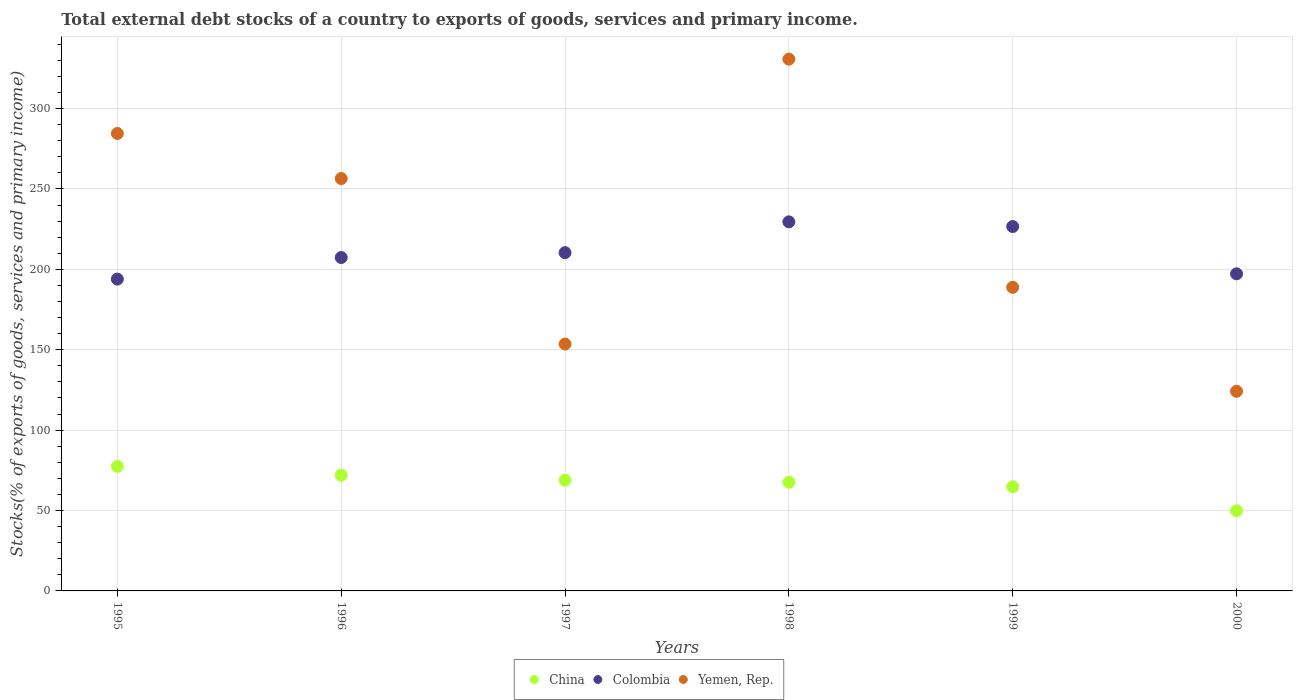How many different coloured dotlines are there?
Give a very brief answer. 3. Is the number of dotlines equal to the number of legend labels?
Your answer should be compact. Yes. What is the total debt stocks in China in 1997?
Offer a terse response. 68.89. Across all years, what is the maximum total debt stocks in Colombia?
Your response must be concise. 229.54. Across all years, what is the minimum total debt stocks in Yemen, Rep.?
Your answer should be very brief. 124.16. In which year was the total debt stocks in Yemen, Rep. maximum?
Provide a short and direct response. 1998. What is the total total debt stocks in China in the graph?
Your response must be concise. 400.57. What is the difference between the total debt stocks in China in 1996 and that in 2000?
Ensure brevity in your answer.  22.11. What is the difference between the total debt stocks in China in 1999 and the total debt stocks in Colombia in 1996?
Your answer should be very brief. -142.57. What is the average total debt stocks in Yemen, Rep. per year?
Offer a very short reply. 223.04. In the year 1998, what is the difference between the total debt stocks in China and total debt stocks in Yemen, Rep.?
Your answer should be compact. -263.14. In how many years, is the total debt stocks in Colombia greater than 200 %?
Ensure brevity in your answer.  4. What is the ratio of the total debt stocks in Colombia in 1995 to that in 1996?
Offer a very short reply. 0.94. What is the difference between the highest and the second highest total debt stocks in Colombia?
Provide a succinct answer. 2.91. What is the difference between the highest and the lowest total debt stocks in Colombia?
Your answer should be very brief. 35.61. Does the total debt stocks in Yemen, Rep. monotonically increase over the years?
Offer a terse response. No. How many dotlines are there?
Give a very brief answer. 3. How many years are there in the graph?
Provide a succinct answer. 6. What is the difference between two consecutive major ticks on the Y-axis?
Your answer should be compact. 50. Does the graph contain any zero values?
Make the answer very short. No. Where does the legend appear in the graph?
Make the answer very short. Bottom center. How many legend labels are there?
Make the answer very short. 3. How are the legend labels stacked?
Offer a very short reply. Horizontal. What is the title of the graph?
Your answer should be very brief. Total external debt stocks of a country to exports of goods, services and primary income. Does "Low income" appear as one of the legend labels in the graph?
Your answer should be very brief. No. What is the label or title of the Y-axis?
Your response must be concise. Stocks(% of exports of goods, services and primary income). What is the Stocks(% of exports of goods, services and primary income) of China in 1995?
Provide a succinct answer. 77.47. What is the Stocks(% of exports of goods, services and primary income) of Colombia in 1995?
Provide a succinct answer. 193.93. What is the Stocks(% of exports of goods, services and primary income) of Yemen, Rep. in 1995?
Your answer should be very brief. 284.52. What is the Stocks(% of exports of goods, services and primary income) of China in 1996?
Ensure brevity in your answer.  71.97. What is the Stocks(% of exports of goods, services and primary income) of Colombia in 1996?
Your response must be concise. 207.36. What is the Stocks(% of exports of goods, services and primary income) in Yemen, Rep. in 1996?
Offer a terse response. 256.49. What is the Stocks(% of exports of goods, services and primary income) in China in 1997?
Ensure brevity in your answer.  68.89. What is the Stocks(% of exports of goods, services and primary income) of Colombia in 1997?
Provide a short and direct response. 210.38. What is the Stocks(% of exports of goods, services and primary income) in Yemen, Rep. in 1997?
Offer a very short reply. 153.54. What is the Stocks(% of exports of goods, services and primary income) in China in 1998?
Offer a very short reply. 67.59. What is the Stocks(% of exports of goods, services and primary income) in Colombia in 1998?
Provide a short and direct response. 229.54. What is the Stocks(% of exports of goods, services and primary income) in Yemen, Rep. in 1998?
Offer a very short reply. 330.74. What is the Stocks(% of exports of goods, services and primary income) of China in 1999?
Provide a succinct answer. 64.79. What is the Stocks(% of exports of goods, services and primary income) of Colombia in 1999?
Provide a short and direct response. 226.63. What is the Stocks(% of exports of goods, services and primary income) in Yemen, Rep. in 1999?
Your answer should be compact. 188.81. What is the Stocks(% of exports of goods, services and primary income) of China in 2000?
Provide a short and direct response. 49.86. What is the Stocks(% of exports of goods, services and primary income) of Colombia in 2000?
Provide a succinct answer. 197.22. What is the Stocks(% of exports of goods, services and primary income) in Yemen, Rep. in 2000?
Offer a very short reply. 124.16. Across all years, what is the maximum Stocks(% of exports of goods, services and primary income) in China?
Give a very brief answer. 77.47. Across all years, what is the maximum Stocks(% of exports of goods, services and primary income) of Colombia?
Keep it short and to the point. 229.54. Across all years, what is the maximum Stocks(% of exports of goods, services and primary income) in Yemen, Rep.?
Provide a succinct answer. 330.74. Across all years, what is the minimum Stocks(% of exports of goods, services and primary income) of China?
Provide a short and direct response. 49.86. Across all years, what is the minimum Stocks(% of exports of goods, services and primary income) in Colombia?
Offer a very short reply. 193.93. Across all years, what is the minimum Stocks(% of exports of goods, services and primary income) of Yemen, Rep.?
Your answer should be very brief. 124.16. What is the total Stocks(% of exports of goods, services and primary income) in China in the graph?
Ensure brevity in your answer.  400.57. What is the total Stocks(% of exports of goods, services and primary income) of Colombia in the graph?
Provide a short and direct response. 1265.05. What is the total Stocks(% of exports of goods, services and primary income) in Yemen, Rep. in the graph?
Offer a very short reply. 1338.26. What is the difference between the Stocks(% of exports of goods, services and primary income) of China in 1995 and that in 1996?
Keep it short and to the point. 5.5. What is the difference between the Stocks(% of exports of goods, services and primary income) in Colombia in 1995 and that in 1996?
Provide a short and direct response. -13.44. What is the difference between the Stocks(% of exports of goods, services and primary income) in Yemen, Rep. in 1995 and that in 1996?
Your response must be concise. 28.03. What is the difference between the Stocks(% of exports of goods, services and primary income) in China in 1995 and that in 1997?
Give a very brief answer. 8.58. What is the difference between the Stocks(% of exports of goods, services and primary income) in Colombia in 1995 and that in 1997?
Give a very brief answer. -16.46. What is the difference between the Stocks(% of exports of goods, services and primary income) of Yemen, Rep. in 1995 and that in 1997?
Your answer should be very brief. 130.98. What is the difference between the Stocks(% of exports of goods, services and primary income) of China in 1995 and that in 1998?
Your answer should be very brief. 9.88. What is the difference between the Stocks(% of exports of goods, services and primary income) in Colombia in 1995 and that in 1998?
Provide a short and direct response. -35.61. What is the difference between the Stocks(% of exports of goods, services and primary income) in Yemen, Rep. in 1995 and that in 1998?
Your response must be concise. -46.21. What is the difference between the Stocks(% of exports of goods, services and primary income) of China in 1995 and that in 1999?
Provide a succinct answer. 12.68. What is the difference between the Stocks(% of exports of goods, services and primary income) in Colombia in 1995 and that in 1999?
Provide a short and direct response. -32.7. What is the difference between the Stocks(% of exports of goods, services and primary income) in Yemen, Rep. in 1995 and that in 1999?
Your answer should be compact. 95.71. What is the difference between the Stocks(% of exports of goods, services and primary income) of China in 1995 and that in 2000?
Give a very brief answer. 27.61. What is the difference between the Stocks(% of exports of goods, services and primary income) of Colombia in 1995 and that in 2000?
Provide a succinct answer. -3.29. What is the difference between the Stocks(% of exports of goods, services and primary income) of Yemen, Rep. in 1995 and that in 2000?
Keep it short and to the point. 160.36. What is the difference between the Stocks(% of exports of goods, services and primary income) of China in 1996 and that in 1997?
Offer a terse response. 3.08. What is the difference between the Stocks(% of exports of goods, services and primary income) of Colombia in 1996 and that in 1997?
Your response must be concise. -3.02. What is the difference between the Stocks(% of exports of goods, services and primary income) of Yemen, Rep. in 1996 and that in 1997?
Your answer should be compact. 102.95. What is the difference between the Stocks(% of exports of goods, services and primary income) of China in 1996 and that in 1998?
Your response must be concise. 4.37. What is the difference between the Stocks(% of exports of goods, services and primary income) in Colombia in 1996 and that in 1998?
Offer a terse response. -22.17. What is the difference between the Stocks(% of exports of goods, services and primary income) in Yemen, Rep. in 1996 and that in 1998?
Your answer should be compact. -74.24. What is the difference between the Stocks(% of exports of goods, services and primary income) of China in 1996 and that in 1999?
Give a very brief answer. 7.17. What is the difference between the Stocks(% of exports of goods, services and primary income) in Colombia in 1996 and that in 1999?
Your response must be concise. -19.26. What is the difference between the Stocks(% of exports of goods, services and primary income) in Yemen, Rep. in 1996 and that in 1999?
Give a very brief answer. 67.68. What is the difference between the Stocks(% of exports of goods, services and primary income) of China in 1996 and that in 2000?
Keep it short and to the point. 22.11. What is the difference between the Stocks(% of exports of goods, services and primary income) in Colombia in 1996 and that in 2000?
Give a very brief answer. 10.14. What is the difference between the Stocks(% of exports of goods, services and primary income) of Yemen, Rep. in 1996 and that in 2000?
Offer a terse response. 132.33. What is the difference between the Stocks(% of exports of goods, services and primary income) in China in 1997 and that in 1998?
Offer a very short reply. 1.29. What is the difference between the Stocks(% of exports of goods, services and primary income) of Colombia in 1997 and that in 1998?
Your answer should be very brief. -19.15. What is the difference between the Stocks(% of exports of goods, services and primary income) of Yemen, Rep. in 1997 and that in 1998?
Your answer should be compact. -177.2. What is the difference between the Stocks(% of exports of goods, services and primary income) of China in 1997 and that in 1999?
Provide a succinct answer. 4.1. What is the difference between the Stocks(% of exports of goods, services and primary income) in Colombia in 1997 and that in 1999?
Provide a succinct answer. -16.24. What is the difference between the Stocks(% of exports of goods, services and primary income) of Yemen, Rep. in 1997 and that in 1999?
Keep it short and to the point. -35.27. What is the difference between the Stocks(% of exports of goods, services and primary income) of China in 1997 and that in 2000?
Give a very brief answer. 19.03. What is the difference between the Stocks(% of exports of goods, services and primary income) of Colombia in 1997 and that in 2000?
Your answer should be very brief. 13.16. What is the difference between the Stocks(% of exports of goods, services and primary income) of Yemen, Rep. in 1997 and that in 2000?
Ensure brevity in your answer.  29.37. What is the difference between the Stocks(% of exports of goods, services and primary income) of China in 1998 and that in 1999?
Offer a terse response. 2.8. What is the difference between the Stocks(% of exports of goods, services and primary income) in Colombia in 1998 and that in 1999?
Provide a short and direct response. 2.91. What is the difference between the Stocks(% of exports of goods, services and primary income) in Yemen, Rep. in 1998 and that in 1999?
Your answer should be very brief. 141.92. What is the difference between the Stocks(% of exports of goods, services and primary income) of China in 1998 and that in 2000?
Give a very brief answer. 17.73. What is the difference between the Stocks(% of exports of goods, services and primary income) of Colombia in 1998 and that in 2000?
Make the answer very short. 32.31. What is the difference between the Stocks(% of exports of goods, services and primary income) in Yemen, Rep. in 1998 and that in 2000?
Keep it short and to the point. 206.57. What is the difference between the Stocks(% of exports of goods, services and primary income) in China in 1999 and that in 2000?
Provide a short and direct response. 14.93. What is the difference between the Stocks(% of exports of goods, services and primary income) of Colombia in 1999 and that in 2000?
Your answer should be very brief. 29.41. What is the difference between the Stocks(% of exports of goods, services and primary income) of Yemen, Rep. in 1999 and that in 2000?
Your response must be concise. 64.65. What is the difference between the Stocks(% of exports of goods, services and primary income) of China in 1995 and the Stocks(% of exports of goods, services and primary income) of Colombia in 1996?
Your answer should be compact. -129.89. What is the difference between the Stocks(% of exports of goods, services and primary income) in China in 1995 and the Stocks(% of exports of goods, services and primary income) in Yemen, Rep. in 1996?
Your answer should be very brief. -179.02. What is the difference between the Stocks(% of exports of goods, services and primary income) in Colombia in 1995 and the Stocks(% of exports of goods, services and primary income) in Yemen, Rep. in 1996?
Keep it short and to the point. -62.57. What is the difference between the Stocks(% of exports of goods, services and primary income) of China in 1995 and the Stocks(% of exports of goods, services and primary income) of Colombia in 1997?
Offer a terse response. -132.91. What is the difference between the Stocks(% of exports of goods, services and primary income) of China in 1995 and the Stocks(% of exports of goods, services and primary income) of Yemen, Rep. in 1997?
Your answer should be very brief. -76.07. What is the difference between the Stocks(% of exports of goods, services and primary income) of Colombia in 1995 and the Stocks(% of exports of goods, services and primary income) of Yemen, Rep. in 1997?
Provide a succinct answer. 40.39. What is the difference between the Stocks(% of exports of goods, services and primary income) in China in 1995 and the Stocks(% of exports of goods, services and primary income) in Colombia in 1998?
Provide a succinct answer. -152.06. What is the difference between the Stocks(% of exports of goods, services and primary income) of China in 1995 and the Stocks(% of exports of goods, services and primary income) of Yemen, Rep. in 1998?
Keep it short and to the point. -253.26. What is the difference between the Stocks(% of exports of goods, services and primary income) of Colombia in 1995 and the Stocks(% of exports of goods, services and primary income) of Yemen, Rep. in 1998?
Keep it short and to the point. -136.81. What is the difference between the Stocks(% of exports of goods, services and primary income) of China in 1995 and the Stocks(% of exports of goods, services and primary income) of Colombia in 1999?
Provide a succinct answer. -149.16. What is the difference between the Stocks(% of exports of goods, services and primary income) of China in 1995 and the Stocks(% of exports of goods, services and primary income) of Yemen, Rep. in 1999?
Offer a very short reply. -111.34. What is the difference between the Stocks(% of exports of goods, services and primary income) in Colombia in 1995 and the Stocks(% of exports of goods, services and primary income) in Yemen, Rep. in 1999?
Your response must be concise. 5.11. What is the difference between the Stocks(% of exports of goods, services and primary income) of China in 1995 and the Stocks(% of exports of goods, services and primary income) of Colombia in 2000?
Offer a very short reply. -119.75. What is the difference between the Stocks(% of exports of goods, services and primary income) in China in 1995 and the Stocks(% of exports of goods, services and primary income) in Yemen, Rep. in 2000?
Ensure brevity in your answer.  -46.69. What is the difference between the Stocks(% of exports of goods, services and primary income) in Colombia in 1995 and the Stocks(% of exports of goods, services and primary income) in Yemen, Rep. in 2000?
Provide a succinct answer. 69.76. What is the difference between the Stocks(% of exports of goods, services and primary income) in China in 1996 and the Stocks(% of exports of goods, services and primary income) in Colombia in 1997?
Ensure brevity in your answer.  -138.42. What is the difference between the Stocks(% of exports of goods, services and primary income) of China in 1996 and the Stocks(% of exports of goods, services and primary income) of Yemen, Rep. in 1997?
Your response must be concise. -81.57. What is the difference between the Stocks(% of exports of goods, services and primary income) of Colombia in 1996 and the Stocks(% of exports of goods, services and primary income) of Yemen, Rep. in 1997?
Offer a terse response. 53.82. What is the difference between the Stocks(% of exports of goods, services and primary income) of China in 1996 and the Stocks(% of exports of goods, services and primary income) of Colombia in 1998?
Offer a terse response. -157.57. What is the difference between the Stocks(% of exports of goods, services and primary income) of China in 1996 and the Stocks(% of exports of goods, services and primary income) of Yemen, Rep. in 1998?
Your answer should be compact. -258.77. What is the difference between the Stocks(% of exports of goods, services and primary income) of Colombia in 1996 and the Stocks(% of exports of goods, services and primary income) of Yemen, Rep. in 1998?
Make the answer very short. -123.37. What is the difference between the Stocks(% of exports of goods, services and primary income) in China in 1996 and the Stocks(% of exports of goods, services and primary income) in Colombia in 1999?
Offer a terse response. -154.66. What is the difference between the Stocks(% of exports of goods, services and primary income) in China in 1996 and the Stocks(% of exports of goods, services and primary income) in Yemen, Rep. in 1999?
Your response must be concise. -116.85. What is the difference between the Stocks(% of exports of goods, services and primary income) in Colombia in 1996 and the Stocks(% of exports of goods, services and primary income) in Yemen, Rep. in 1999?
Provide a succinct answer. 18.55. What is the difference between the Stocks(% of exports of goods, services and primary income) in China in 1996 and the Stocks(% of exports of goods, services and primary income) in Colombia in 2000?
Offer a terse response. -125.25. What is the difference between the Stocks(% of exports of goods, services and primary income) in China in 1996 and the Stocks(% of exports of goods, services and primary income) in Yemen, Rep. in 2000?
Your answer should be compact. -52.2. What is the difference between the Stocks(% of exports of goods, services and primary income) of Colombia in 1996 and the Stocks(% of exports of goods, services and primary income) of Yemen, Rep. in 2000?
Provide a succinct answer. 83.2. What is the difference between the Stocks(% of exports of goods, services and primary income) of China in 1997 and the Stocks(% of exports of goods, services and primary income) of Colombia in 1998?
Provide a short and direct response. -160.65. What is the difference between the Stocks(% of exports of goods, services and primary income) in China in 1997 and the Stocks(% of exports of goods, services and primary income) in Yemen, Rep. in 1998?
Offer a very short reply. -261.85. What is the difference between the Stocks(% of exports of goods, services and primary income) in Colombia in 1997 and the Stocks(% of exports of goods, services and primary income) in Yemen, Rep. in 1998?
Offer a terse response. -120.35. What is the difference between the Stocks(% of exports of goods, services and primary income) of China in 1997 and the Stocks(% of exports of goods, services and primary income) of Colombia in 1999?
Make the answer very short. -157.74. What is the difference between the Stocks(% of exports of goods, services and primary income) of China in 1997 and the Stocks(% of exports of goods, services and primary income) of Yemen, Rep. in 1999?
Offer a terse response. -119.92. What is the difference between the Stocks(% of exports of goods, services and primary income) of Colombia in 1997 and the Stocks(% of exports of goods, services and primary income) of Yemen, Rep. in 1999?
Offer a very short reply. 21.57. What is the difference between the Stocks(% of exports of goods, services and primary income) in China in 1997 and the Stocks(% of exports of goods, services and primary income) in Colombia in 2000?
Your answer should be compact. -128.33. What is the difference between the Stocks(% of exports of goods, services and primary income) in China in 1997 and the Stocks(% of exports of goods, services and primary income) in Yemen, Rep. in 2000?
Provide a short and direct response. -55.28. What is the difference between the Stocks(% of exports of goods, services and primary income) in Colombia in 1997 and the Stocks(% of exports of goods, services and primary income) in Yemen, Rep. in 2000?
Provide a succinct answer. 86.22. What is the difference between the Stocks(% of exports of goods, services and primary income) in China in 1998 and the Stocks(% of exports of goods, services and primary income) in Colombia in 1999?
Your answer should be compact. -159.03. What is the difference between the Stocks(% of exports of goods, services and primary income) of China in 1998 and the Stocks(% of exports of goods, services and primary income) of Yemen, Rep. in 1999?
Offer a very short reply. -121.22. What is the difference between the Stocks(% of exports of goods, services and primary income) in Colombia in 1998 and the Stocks(% of exports of goods, services and primary income) in Yemen, Rep. in 1999?
Make the answer very short. 40.72. What is the difference between the Stocks(% of exports of goods, services and primary income) in China in 1998 and the Stocks(% of exports of goods, services and primary income) in Colombia in 2000?
Offer a terse response. -129.63. What is the difference between the Stocks(% of exports of goods, services and primary income) of China in 1998 and the Stocks(% of exports of goods, services and primary income) of Yemen, Rep. in 2000?
Make the answer very short. -56.57. What is the difference between the Stocks(% of exports of goods, services and primary income) in Colombia in 1998 and the Stocks(% of exports of goods, services and primary income) in Yemen, Rep. in 2000?
Your answer should be very brief. 105.37. What is the difference between the Stocks(% of exports of goods, services and primary income) of China in 1999 and the Stocks(% of exports of goods, services and primary income) of Colombia in 2000?
Keep it short and to the point. -132.43. What is the difference between the Stocks(% of exports of goods, services and primary income) of China in 1999 and the Stocks(% of exports of goods, services and primary income) of Yemen, Rep. in 2000?
Offer a very short reply. -59.37. What is the difference between the Stocks(% of exports of goods, services and primary income) in Colombia in 1999 and the Stocks(% of exports of goods, services and primary income) in Yemen, Rep. in 2000?
Keep it short and to the point. 102.46. What is the average Stocks(% of exports of goods, services and primary income) of China per year?
Keep it short and to the point. 66.76. What is the average Stocks(% of exports of goods, services and primary income) of Colombia per year?
Keep it short and to the point. 210.84. What is the average Stocks(% of exports of goods, services and primary income) in Yemen, Rep. per year?
Provide a succinct answer. 223.04. In the year 1995, what is the difference between the Stocks(% of exports of goods, services and primary income) in China and Stocks(% of exports of goods, services and primary income) in Colombia?
Keep it short and to the point. -116.46. In the year 1995, what is the difference between the Stocks(% of exports of goods, services and primary income) of China and Stocks(% of exports of goods, services and primary income) of Yemen, Rep.?
Your response must be concise. -207.05. In the year 1995, what is the difference between the Stocks(% of exports of goods, services and primary income) in Colombia and Stocks(% of exports of goods, services and primary income) in Yemen, Rep.?
Provide a short and direct response. -90.6. In the year 1996, what is the difference between the Stocks(% of exports of goods, services and primary income) of China and Stocks(% of exports of goods, services and primary income) of Colombia?
Your response must be concise. -135.4. In the year 1996, what is the difference between the Stocks(% of exports of goods, services and primary income) of China and Stocks(% of exports of goods, services and primary income) of Yemen, Rep.?
Provide a succinct answer. -184.52. In the year 1996, what is the difference between the Stocks(% of exports of goods, services and primary income) in Colombia and Stocks(% of exports of goods, services and primary income) in Yemen, Rep.?
Offer a terse response. -49.13. In the year 1997, what is the difference between the Stocks(% of exports of goods, services and primary income) of China and Stocks(% of exports of goods, services and primary income) of Colombia?
Give a very brief answer. -141.49. In the year 1997, what is the difference between the Stocks(% of exports of goods, services and primary income) in China and Stocks(% of exports of goods, services and primary income) in Yemen, Rep.?
Your response must be concise. -84.65. In the year 1997, what is the difference between the Stocks(% of exports of goods, services and primary income) in Colombia and Stocks(% of exports of goods, services and primary income) in Yemen, Rep.?
Your answer should be compact. 56.84. In the year 1998, what is the difference between the Stocks(% of exports of goods, services and primary income) in China and Stocks(% of exports of goods, services and primary income) in Colombia?
Provide a succinct answer. -161.94. In the year 1998, what is the difference between the Stocks(% of exports of goods, services and primary income) in China and Stocks(% of exports of goods, services and primary income) in Yemen, Rep.?
Give a very brief answer. -263.14. In the year 1998, what is the difference between the Stocks(% of exports of goods, services and primary income) of Colombia and Stocks(% of exports of goods, services and primary income) of Yemen, Rep.?
Ensure brevity in your answer.  -101.2. In the year 1999, what is the difference between the Stocks(% of exports of goods, services and primary income) in China and Stocks(% of exports of goods, services and primary income) in Colombia?
Offer a terse response. -161.83. In the year 1999, what is the difference between the Stocks(% of exports of goods, services and primary income) of China and Stocks(% of exports of goods, services and primary income) of Yemen, Rep.?
Provide a short and direct response. -124.02. In the year 1999, what is the difference between the Stocks(% of exports of goods, services and primary income) in Colombia and Stocks(% of exports of goods, services and primary income) in Yemen, Rep.?
Provide a succinct answer. 37.81. In the year 2000, what is the difference between the Stocks(% of exports of goods, services and primary income) in China and Stocks(% of exports of goods, services and primary income) in Colombia?
Ensure brevity in your answer.  -147.36. In the year 2000, what is the difference between the Stocks(% of exports of goods, services and primary income) of China and Stocks(% of exports of goods, services and primary income) of Yemen, Rep.?
Offer a terse response. -74.3. In the year 2000, what is the difference between the Stocks(% of exports of goods, services and primary income) in Colombia and Stocks(% of exports of goods, services and primary income) in Yemen, Rep.?
Give a very brief answer. 73.06. What is the ratio of the Stocks(% of exports of goods, services and primary income) in China in 1995 to that in 1996?
Provide a succinct answer. 1.08. What is the ratio of the Stocks(% of exports of goods, services and primary income) in Colombia in 1995 to that in 1996?
Provide a short and direct response. 0.94. What is the ratio of the Stocks(% of exports of goods, services and primary income) of Yemen, Rep. in 1995 to that in 1996?
Offer a terse response. 1.11. What is the ratio of the Stocks(% of exports of goods, services and primary income) of China in 1995 to that in 1997?
Make the answer very short. 1.12. What is the ratio of the Stocks(% of exports of goods, services and primary income) of Colombia in 1995 to that in 1997?
Give a very brief answer. 0.92. What is the ratio of the Stocks(% of exports of goods, services and primary income) of Yemen, Rep. in 1995 to that in 1997?
Make the answer very short. 1.85. What is the ratio of the Stocks(% of exports of goods, services and primary income) of China in 1995 to that in 1998?
Keep it short and to the point. 1.15. What is the ratio of the Stocks(% of exports of goods, services and primary income) of Colombia in 1995 to that in 1998?
Provide a short and direct response. 0.84. What is the ratio of the Stocks(% of exports of goods, services and primary income) of Yemen, Rep. in 1995 to that in 1998?
Provide a short and direct response. 0.86. What is the ratio of the Stocks(% of exports of goods, services and primary income) in China in 1995 to that in 1999?
Make the answer very short. 1.2. What is the ratio of the Stocks(% of exports of goods, services and primary income) in Colombia in 1995 to that in 1999?
Give a very brief answer. 0.86. What is the ratio of the Stocks(% of exports of goods, services and primary income) in Yemen, Rep. in 1995 to that in 1999?
Give a very brief answer. 1.51. What is the ratio of the Stocks(% of exports of goods, services and primary income) in China in 1995 to that in 2000?
Your response must be concise. 1.55. What is the ratio of the Stocks(% of exports of goods, services and primary income) of Colombia in 1995 to that in 2000?
Provide a succinct answer. 0.98. What is the ratio of the Stocks(% of exports of goods, services and primary income) of Yemen, Rep. in 1995 to that in 2000?
Provide a succinct answer. 2.29. What is the ratio of the Stocks(% of exports of goods, services and primary income) of China in 1996 to that in 1997?
Ensure brevity in your answer.  1.04. What is the ratio of the Stocks(% of exports of goods, services and primary income) in Colombia in 1996 to that in 1997?
Ensure brevity in your answer.  0.99. What is the ratio of the Stocks(% of exports of goods, services and primary income) of Yemen, Rep. in 1996 to that in 1997?
Your answer should be very brief. 1.67. What is the ratio of the Stocks(% of exports of goods, services and primary income) of China in 1996 to that in 1998?
Keep it short and to the point. 1.06. What is the ratio of the Stocks(% of exports of goods, services and primary income) in Colombia in 1996 to that in 1998?
Your answer should be very brief. 0.9. What is the ratio of the Stocks(% of exports of goods, services and primary income) in Yemen, Rep. in 1996 to that in 1998?
Your answer should be compact. 0.78. What is the ratio of the Stocks(% of exports of goods, services and primary income) in China in 1996 to that in 1999?
Provide a succinct answer. 1.11. What is the ratio of the Stocks(% of exports of goods, services and primary income) of Colombia in 1996 to that in 1999?
Give a very brief answer. 0.92. What is the ratio of the Stocks(% of exports of goods, services and primary income) of Yemen, Rep. in 1996 to that in 1999?
Your answer should be very brief. 1.36. What is the ratio of the Stocks(% of exports of goods, services and primary income) in China in 1996 to that in 2000?
Give a very brief answer. 1.44. What is the ratio of the Stocks(% of exports of goods, services and primary income) in Colombia in 1996 to that in 2000?
Your response must be concise. 1.05. What is the ratio of the Stocks(% of exports of goods, services and primary income) in Yemen, Rep. in 1996 to that in 2000?
Provide a short and direct response. 2.07. What is the ratio of the Stocks(% of exports of goods, services and primary income) of China in 1997 to that in 1998?
Offer a terse response. 1.02. What is the ratio of the Stocks(% of exports of goods, services and primary income) of Colombia in 1997 to that in 1998?
Give a very brief answer. 0.92. What is the ratio of the Stocks(% of exports of goods, services and primary income) of Yemen, Rep. in 1997 to that in 1998?
Make the answer very short. 0.46. What is the ratio of the Stocks(% of exports of goods, services and primary income) of China in 1997 to that in 1999?
Offer a terse response. 1.06. What is the ratio of the Stocks(% of exports of goods, services and primary income) in Colombia in 1997 to that in 1999?
Ensure brevity in your answer.  0.93. What is the ratio of the Stocks(% of exports of goods, services and primary income) in Yemen, Rep. in 1997 to that in 1999?
Provide a succinct answer. 0.81. What is the ratio of the Stocks(% of exports of goods, services and primary income) in China in 1997 to that in 2000?
Make the answer very short. 1.38. What is the ratio of the Stocks(% of exports of goods, services and primary income) in Colombia in 1997 to that in 2000?
Provide a succinct answer. 1.07. What is the ratio of the Stocks(% of exports of goods, services and primary income) of Yemen, Rep. in 1997 to that in 2000?
Your response must be concise. 1.24. What is the ratio of the Stocks(% of exports of goods, services and primary income) of China in 1998 to that in 1999?
Provide a short and direct response. 1.04. What is the ratio of the Stocks(% of exports of goods, services and primary income) in Colombia in 1998 to that in 1999?
Provide a short and direct response. 1.01. What is the ratio of the Stocks(% of exports of goods, services and primary income) of Yemen, Rep. in 1998 to that in 1999?
Your answer should be compact. 1.75. What is the ratio of the Stocks(% of exports of goods, services and primary income) of China in 1998 to that in 2000?
Provide a short and direct response. 1.36. What is the ratio of the Stocks(% of exports of goods, services and primary income) of Colombia in 1998 to that in 2000?
Make the answer very short. 1.16. What is the ratio of the Stocks(% of exports of goods, services and primary income) in Yemen, Rep. in 1998 to that in 2000?
Offer a terse response. 2.66. What is the ratio of the Stocks(% of exports of goods, services and primary income) of China in 1999 to that in 2000?
Make the answer very short. 1.3. What is the ratio of the Stocks(% of exports of goods, services and primary income) in Colombia in 1999 to that in 2000?
Give a very brief answer. 1.15. What is the ratio of the Stocks(% of exports of goods, services and primary income) of Yemen, Rep. in 1999 to that in 2000?
Your answer should be compact. 1.52. What is the difference between the highest and the second highest Stocks(% of exports of goods, services and primary income) in China?
Provide a succinct answer. 5.5. What is the difference between the highest and the second highest Stocks(% of exports of goods, services and primary income) of Colombia?
Make the answer very short. 2.91. What is the difference between the highest and the second highest Stocks(% of exports of goods, services and primary income) in Yemen, Rep.?
Your response must be concise. 46.21. What is the difference between the highest and the lowest Stocks(% of exports of goods, services and primary income) of China?
Your answer should be very brief. 27.61. What is the difference between the highest and the lowest Stocks(% of exports of goods, services and primary income) in Colombia?
Your answer should be compact. 35.61. What is the difference between the highest and the lowest Stocks(% of exports of goods, services and primary income) in Yemen, Rep.?
Offer a very short reply. 206.57. 